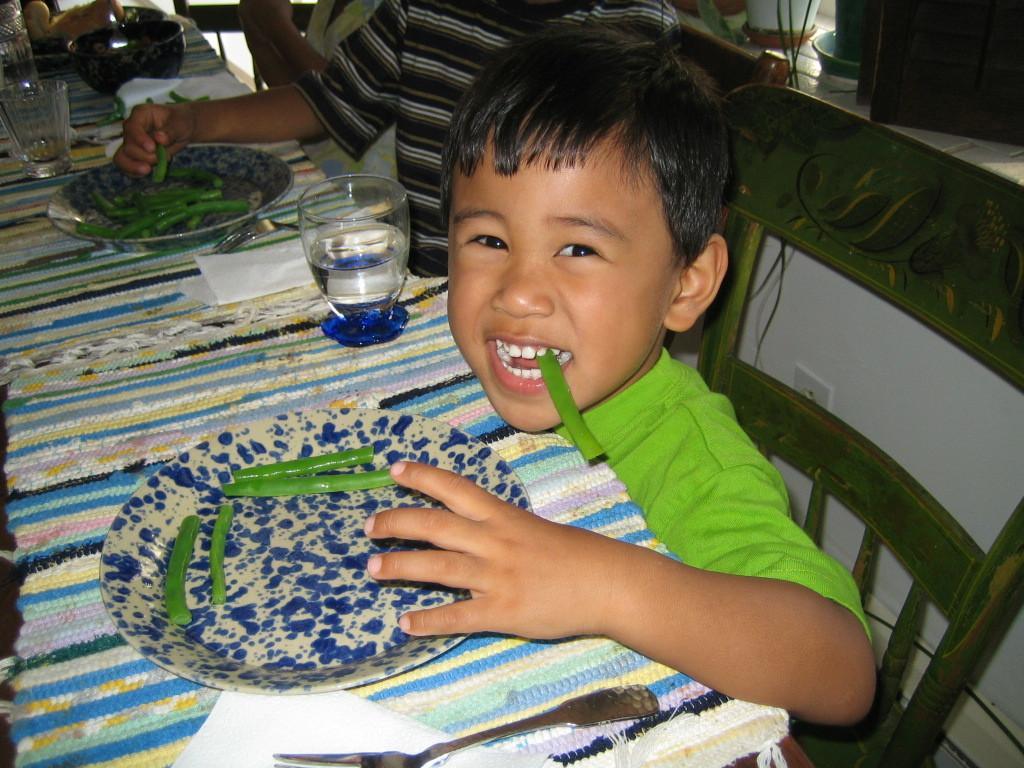How would you summarize this image in a sentence or two? In this picture we can observe a boy sitting in the chair, wearing green color shirt. In front of him there is a table on which we can observe a table mat, plate and a glass with some water in it. We can observe tissues on the table. Beside the boy there are two persons sitting in the chairs. We can observe a bowl on the table, in the background. 